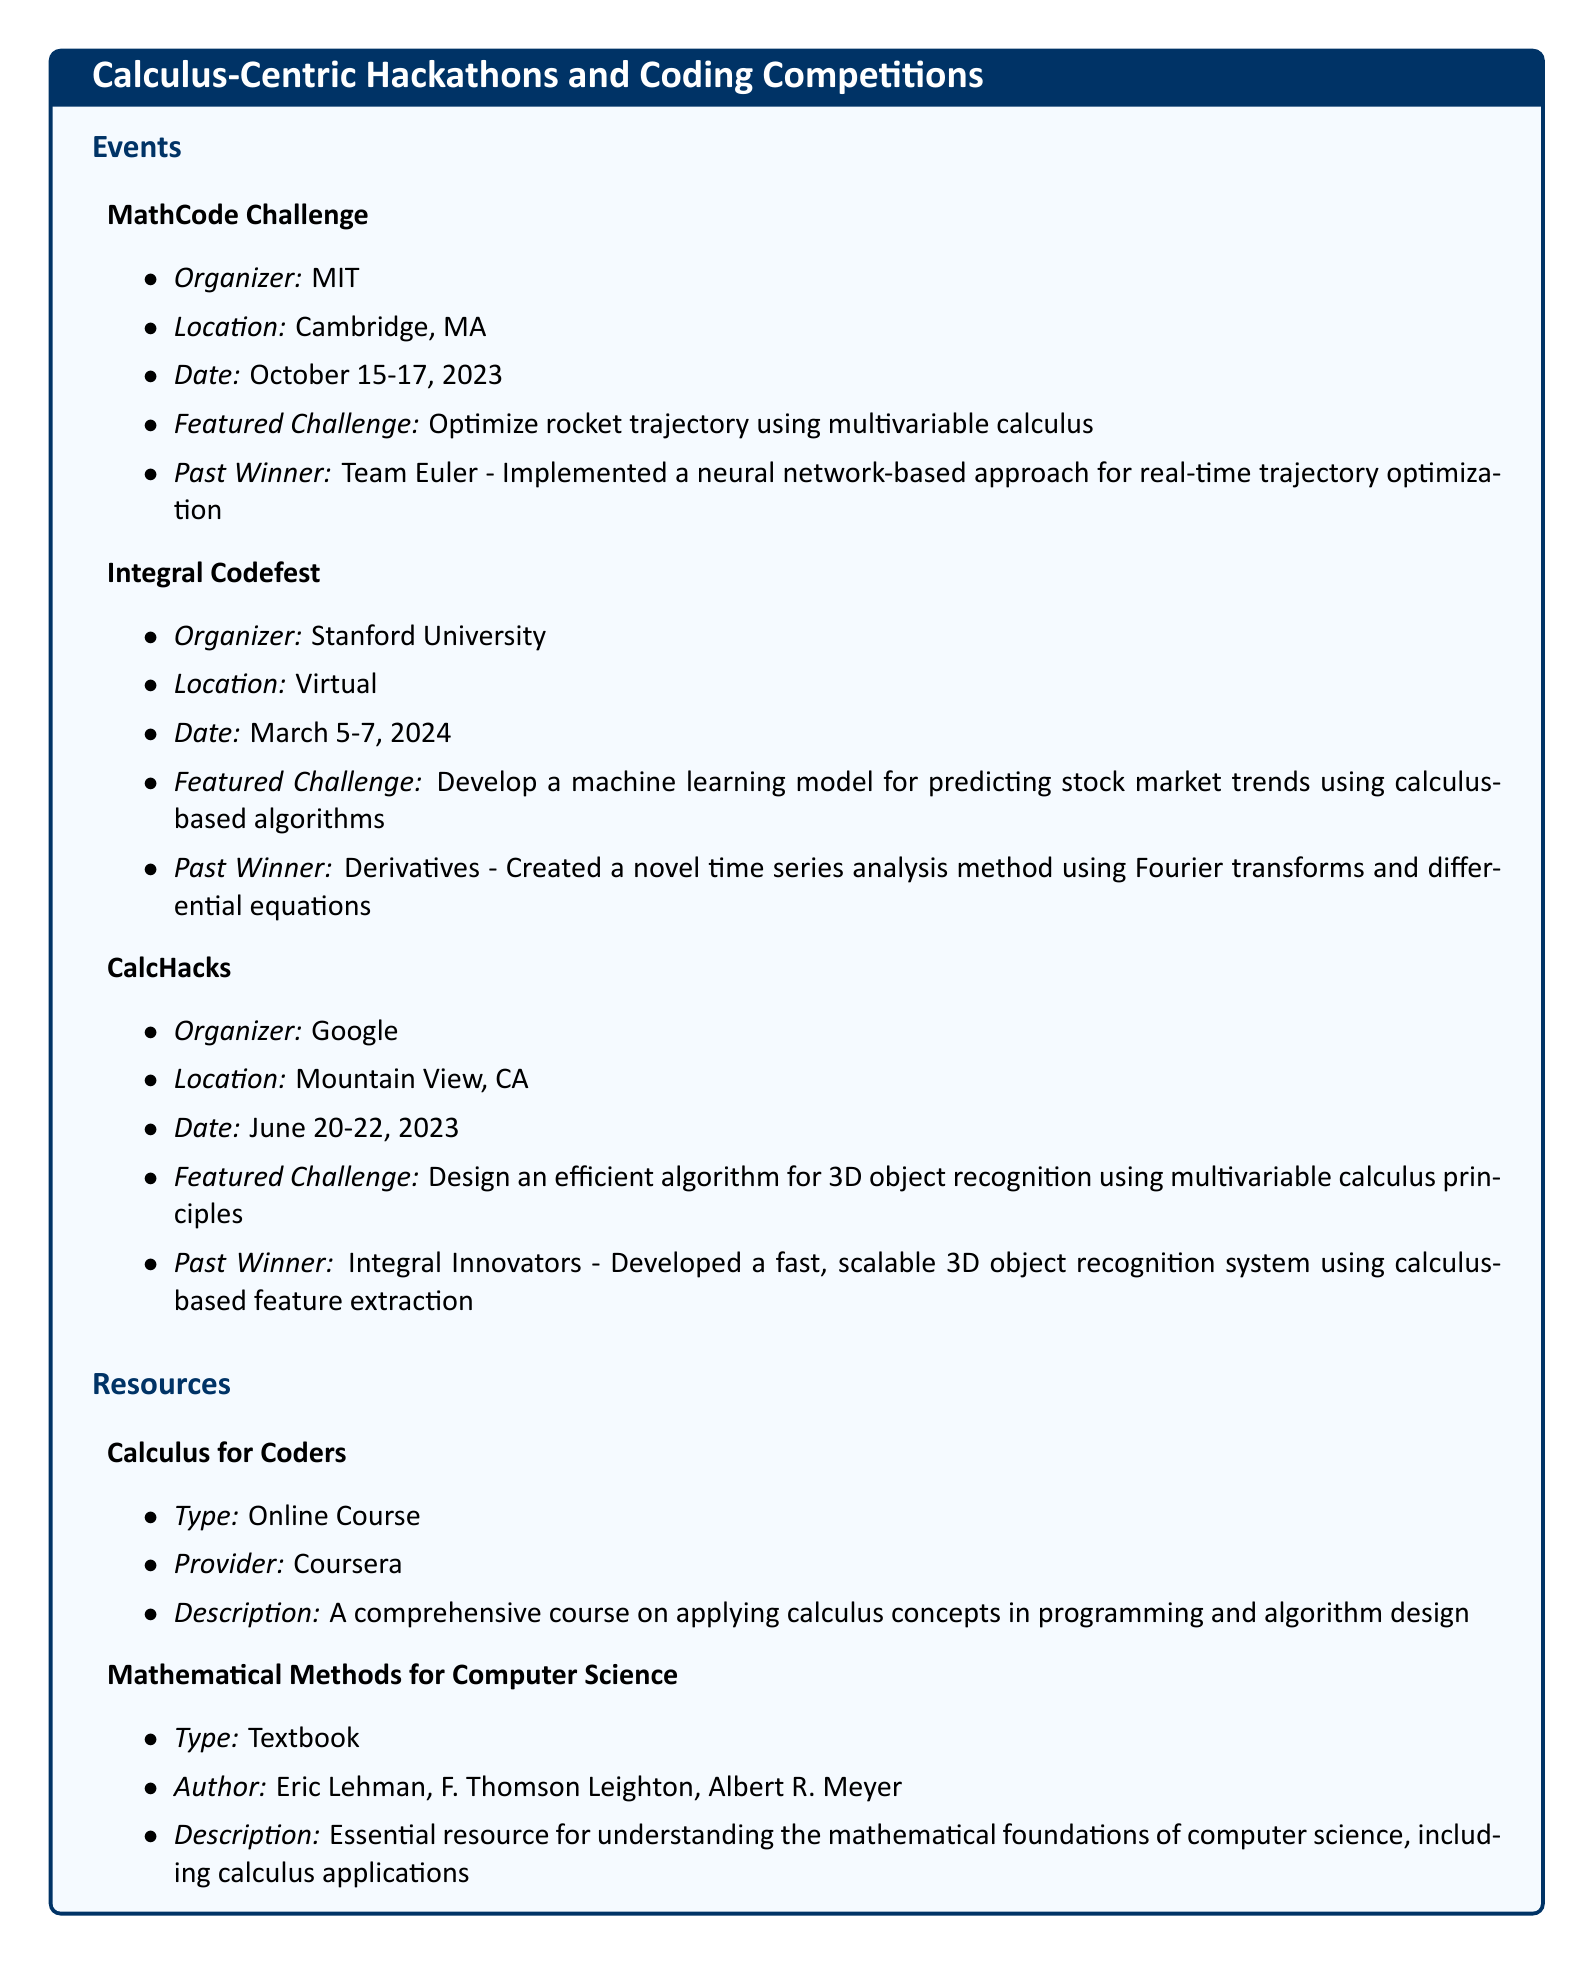What is the name of the hackathon organized by MIT? The document lists the MathCode Challenge as the hackathon organized by MIT.
Answer: MathCode Challenge When is the Integral Codefest scheduled? The date for the Integral Codefest is mentioned in the document as March 5-7, 2024.
Answer: March 5-7, 2024 Who were the past winners of CalcHacks? The document states that a team named Integral Innovators was the past winner of CalcHacks.
Answer: Integral Innovators What type of resource is "Calculus for Coders"? According to the document, "Calculus for Coders" is categorized as an online course.
Answer: Online Course What challenge did Team Euler tackle in the MathCode Challenge? The document describes that Team Euler optimized rocket trajectory using multivariable calculus.
Answer: Optimize rocket trajectory using multivariable calculus Which university organizes the MathCode Challenge? The document specifies MIT as the organizing university for the MathCode Challenge.
Answer: MIT What is the focus of the featured challenge at CalcHacks? The challenge at CalcHacks is focused on designing an efficient algorithm for 3D object recognition.
Answer: Design an efficient algorithm for 3D object recognition Who is the author of "Mathematical Methods for Computer Science"? The document lists Eric Lehman, F. Thomson Leighton, and Albert R. Meyer as the authors.
Answer: Eric Lehman, F. Thomson Leighton, Albert R. Meyer What was a key aspect of the winning solution by Derivatives? The document mentions that Derivatives created a novel time series analysis method using Fourier transforms and differential equations.
Answer: Novel time series analysis method using Fourier transforms and differential equations 